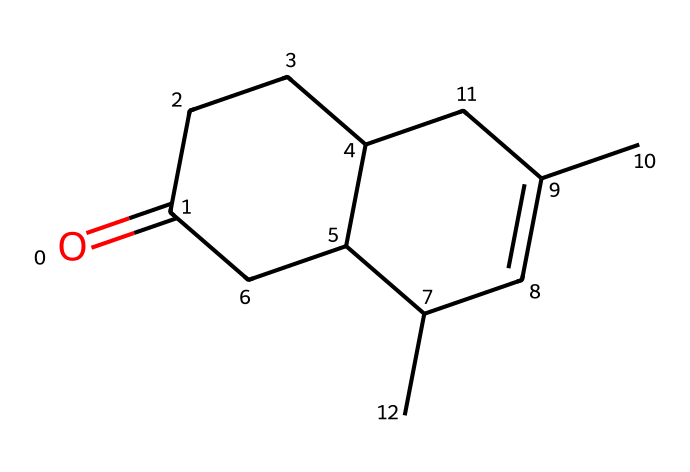What is the main functional group in this compound? The structure shows a carbonyl group (C=O) present at the beginning of the SMILES notation, which identifies it as a ketone.
Answer: carbonyl How many rings are present in this chemical structure? By analyzing the connections in the SMILES notation, we see two ring structures based on the numbers (1 and 2) used in the SMILES that indicate the starting and ending points of rings.
Answer: two What type of compound is nepetalactone classified as? The product of the molecular structure shows it has a cyclic structure with a lactone formation described by its own name, suggesting it falls under the category of cyclic esters.
Answer: lactone What is the total number of carbon atoms in nepetalactone? To determine the number of carbon atoms, we can count the "C" characters in the SMILES representation. Counting gives us ten carbon atoms present in the structure.
Answer: ten Which feature of nepetalactone contributes to the attraction of cats? The presence of the specific structure and functional groups (a lactone structure) provides the chemical properties that evoke a response in cats, particularly triggering sensory receptors.
Answer: lactone structure Is there a double bond present in nepetalactone? Observing the SMILES notation shows that there are connections marked by "C=C," indicating at least one double bond is present in the structure.
Answer: yes What property does the cyclic structure of nepetalactone provide? The cyclic arrangement typically enhances the stability and unique reactivity patterns of the molecule, which play a role in how it interacts with receptors in cats.
Answer: stability 